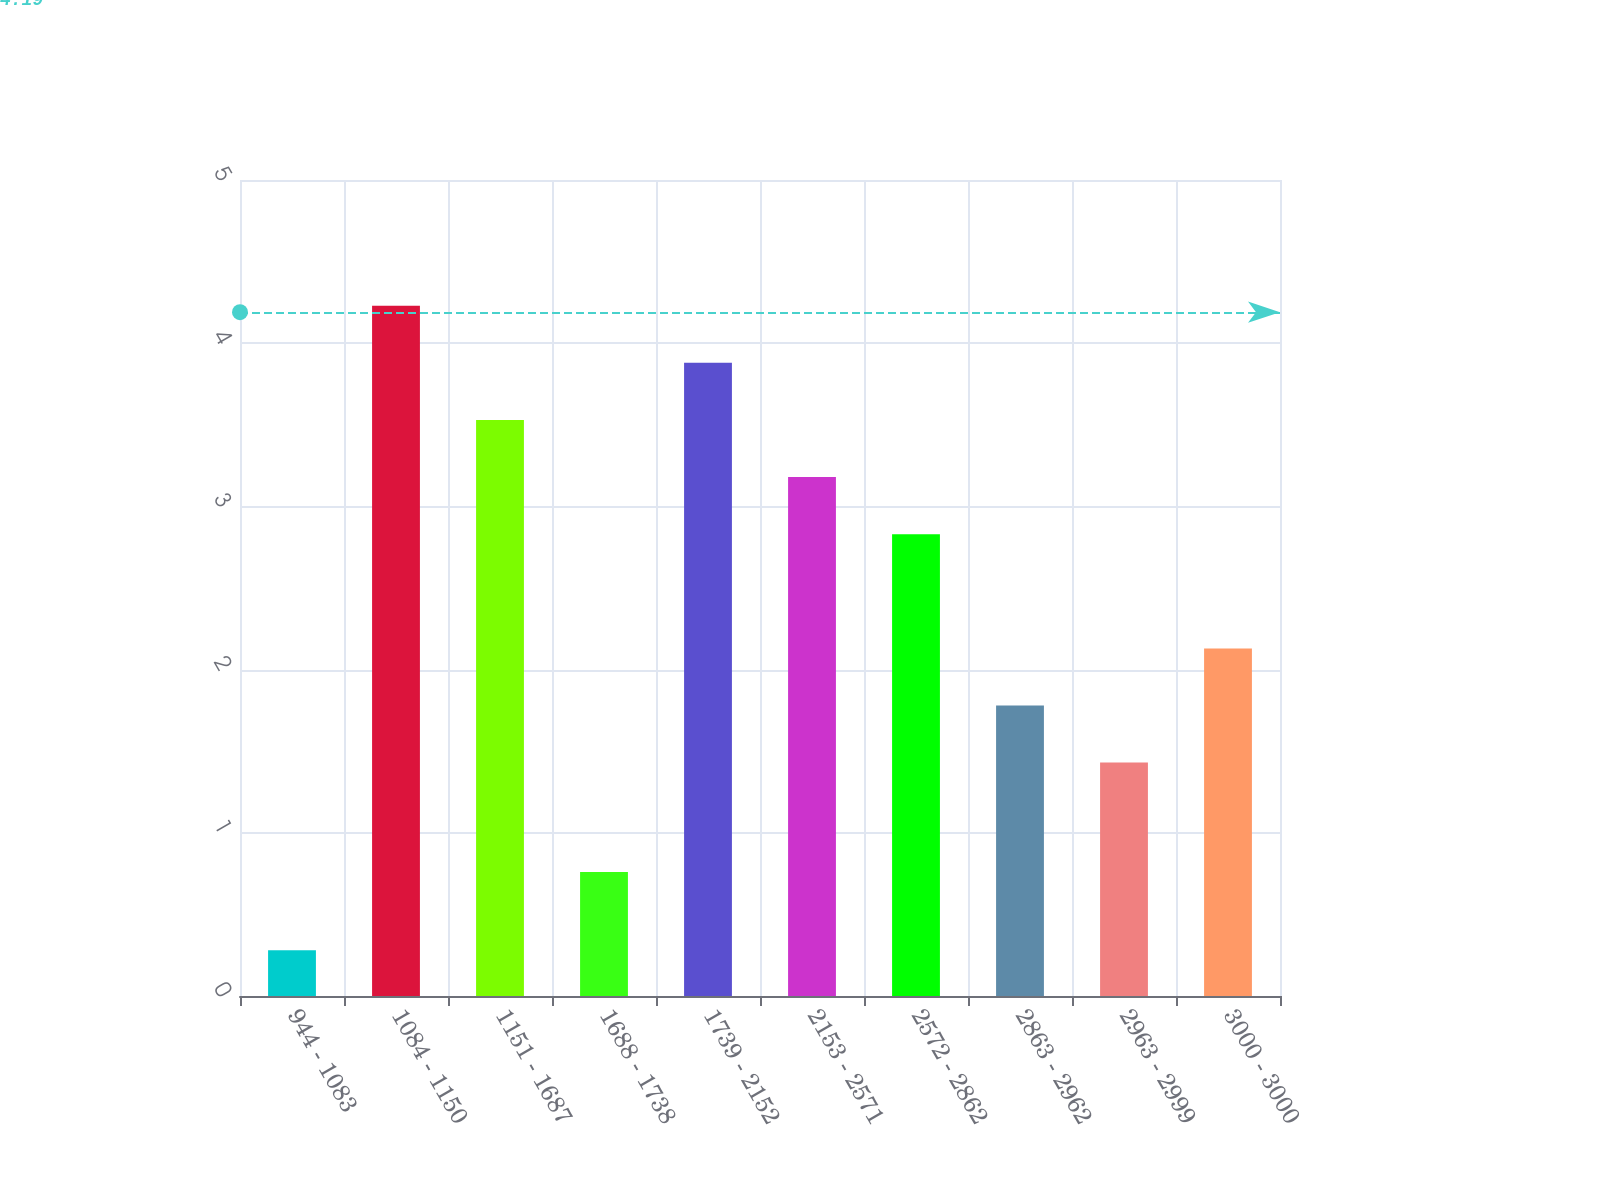Convert chart. <chart><loc_0><loc_0><loc_500><loc_500><bar_chart><fcel>944 - 1083<fcel>1084 - 1150<fcel>1151 - 1687<fcel>1688 - 1738<fcel>1739 - 2152<fcel>2153 - 2571<fcel>2572 - 2862<fcel>2863 - 2962<fcel>2963 - 2999<fcel>3000 - 3000<nl><fcel>0.28<fcel>4.23<fcel>3.53<fcel>0.76<fcel>3.88<fcel>3.18<fcel>2.83<fcel>1.78<fcel>1.43<fcel>2.13<nl></chart> 